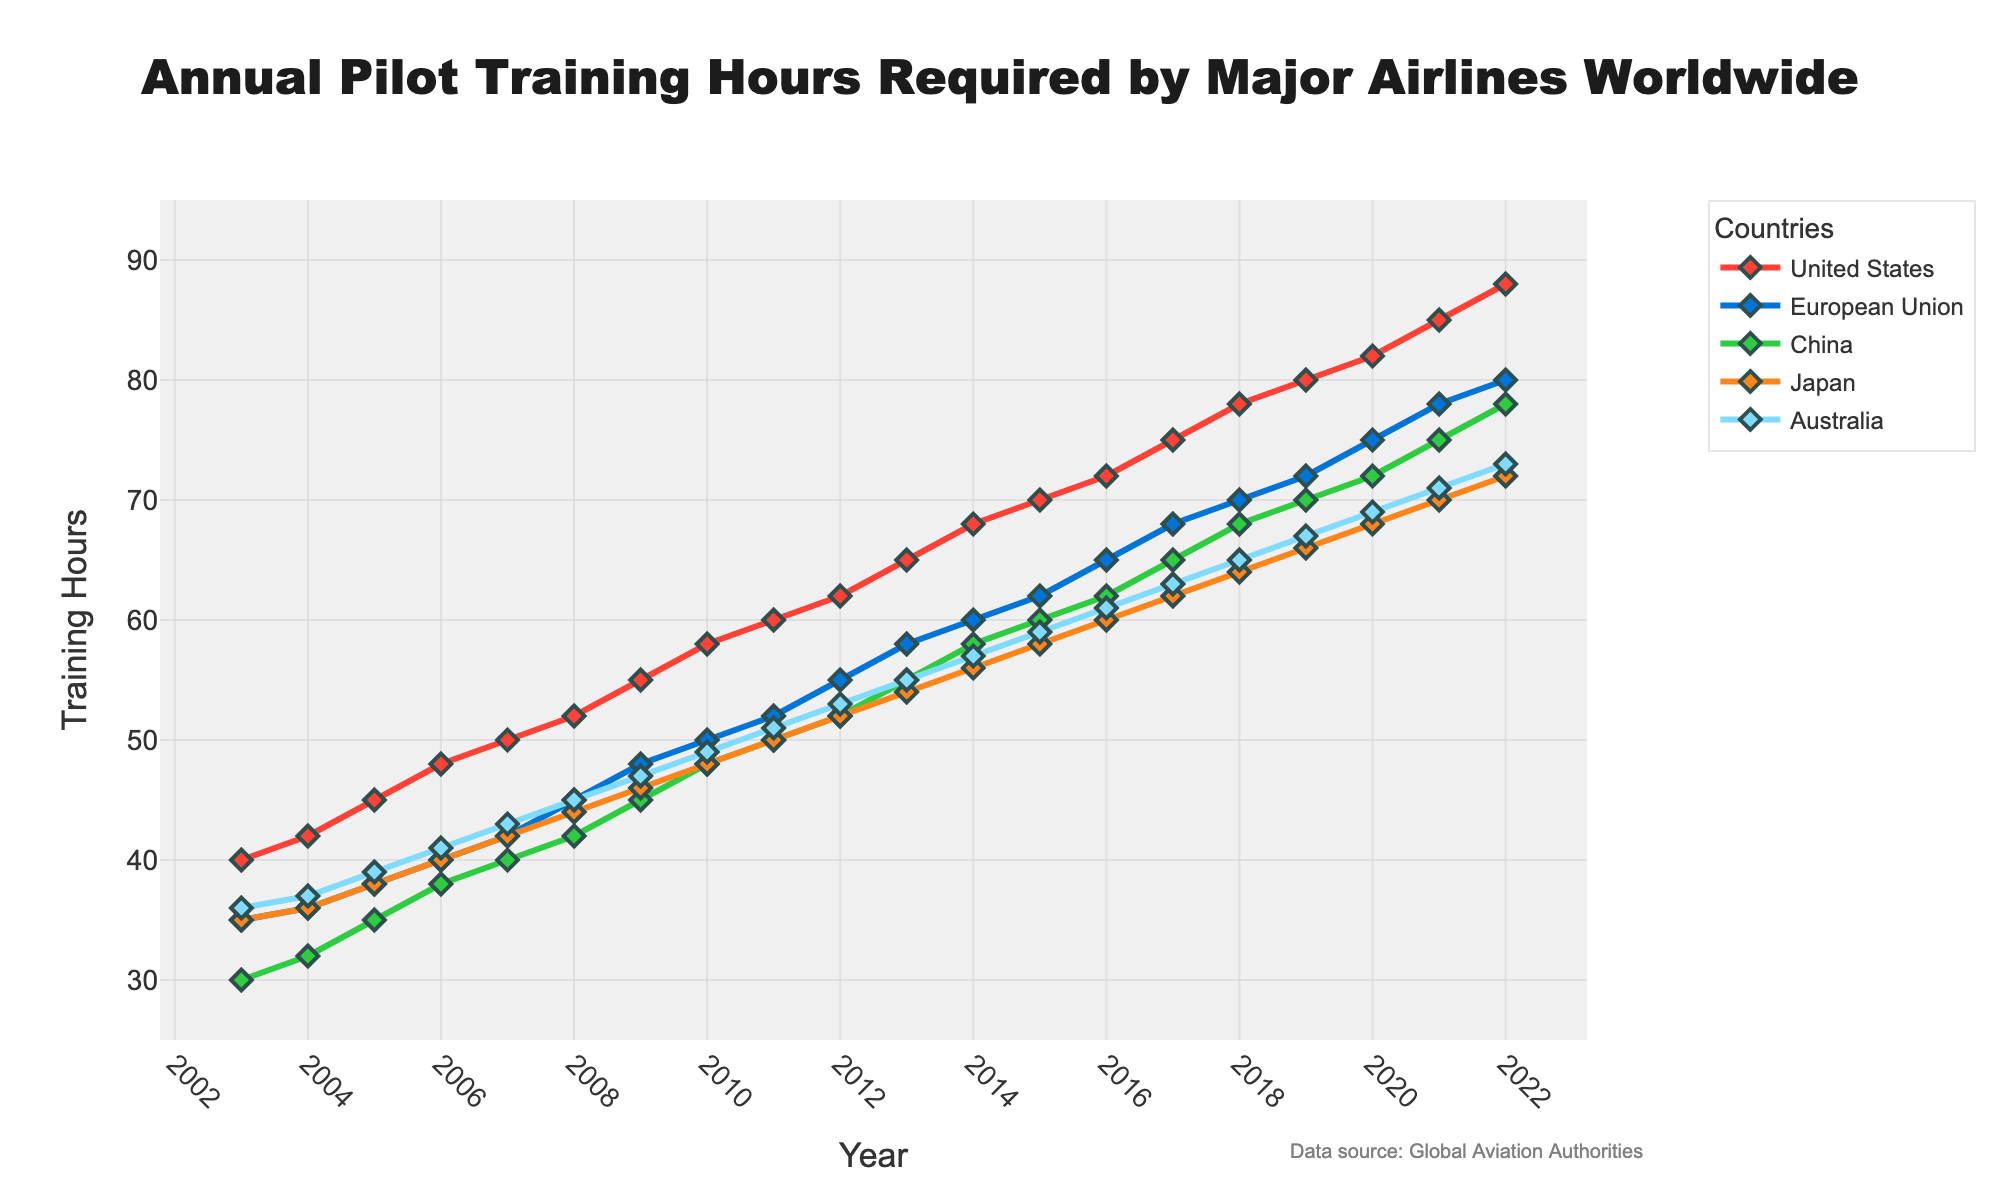How did the training hours for pilots in the United States change from 2010 to 2020? In 2010, the training hours for pilots in the United States were 58 hours. By 2020, this had increased to 82 hours. The difference is 82 - 58 = 24 hours, so the training hours increased by 24 hours over this period.
Answer: Increased by 24 hours During which year were the training hours for pilots in China and Japan the same? By observing the data, we can see that the training hours for pilots in China and Japan were the same in 2015, both at 60 hours.
Answer: 2015 What is the overall trend of pilot training hours required in Australia between 2003 and 2022? The training hours in Australia increased from 36 hours in 2003 to 73 hours in 2022, showing a generally upward trend.
Answer: Upward trend In which year did the European Union first surpass 70 training hours? By checking the data, the European Union first surpassed 70 training hours in 2019 with 72 training hours.
Answer: 2019 What is the difference in training hours between the country with the highest and lowest values in 2021? In 2021, the highest training hours were in the United States with 85 hours, and the lowest was in Japan with 70 hours. The difference is 85 - 70 = 15 hours.
Answer: 15 hours By how many hours did the training requirements for pilots in Japan increase from 2011 to 2017? In 2011, Japan's training hours were 50 hours, and in 2017, it increased to 62 hours. The increase is 62 - 50 = 12 hours.
Answer: 12 hours Which color line represents the pilot training hours in Japan? The plot's legend indicates that Japan is represented by the green line.
Answer: Green 